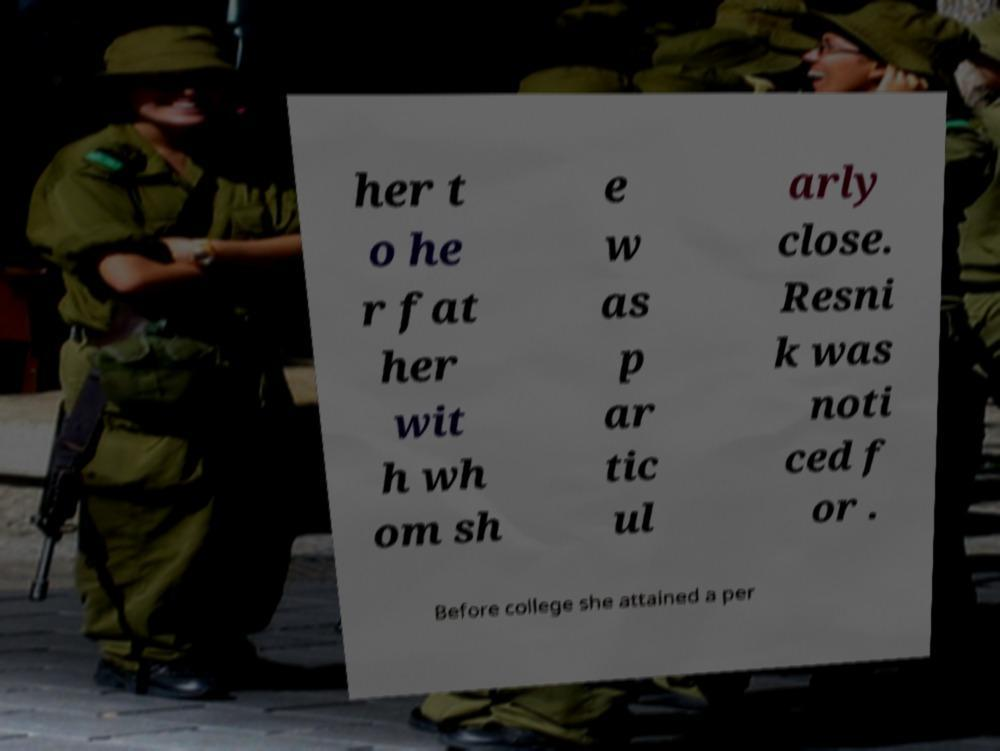For documentation purposes, I need the text within this image transcribed. Could you provide that? her t o he r fat her wit h wh om sh e w as p ar tic ul arly close. Resni k was noti ced f or . Before college she attained a per 